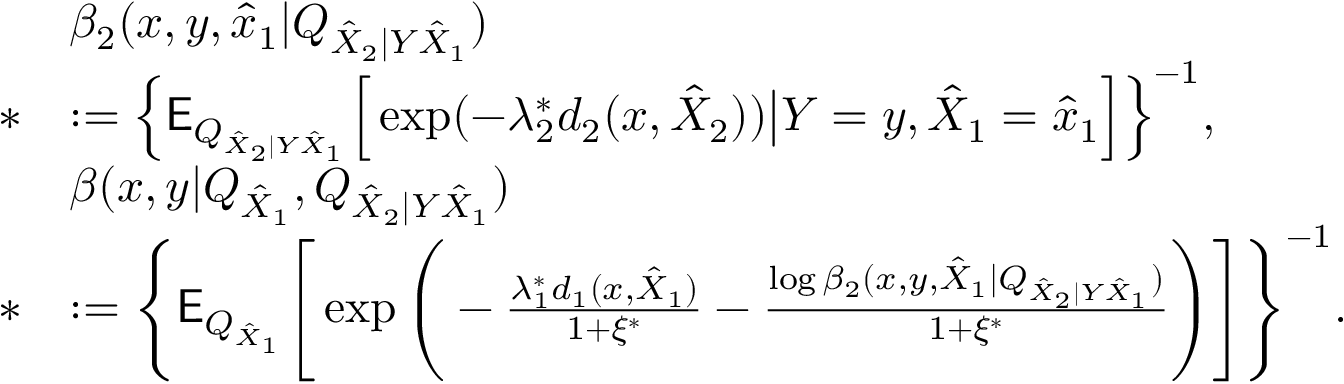Convert formula to latex. <formula><loc_0><loc_0><loc_500><loc_500>\begin{array} { r l } & { \beta _ { 2 } ( x , y , \hat { x } _ { 1 } | Q _ { \hat { X } _ { 2 } | Y \hat { X } _ { 1 } } ) } \\ { * } & { \colon = \Big \{ E _ { Q _ { \hat { X } _ { 2 } | Y \hat { X } _ { 1 } } } \Big [ \exp ( - \lambda _ { 2 } ^ { * } d _ { 2 } ( x , \hat { X } _ { 2 } ) ) \Big | Y = y , \hat { X } _ { 1 } = \hat { x } _ { 1 } \Big ] \Big \} ^ { - 1 } , } \\ & { \beta ( x , y | Q _ { \hat { X } _ { 1 } } , Q _ { \hat { X } _ { 2 } | Y \hat { X } _ { 1 } } ) } \\ { * } & { \colon = \Big \{ E _ { Q _ { \hat { X } _ { 1 } } } \Big [ \exp \Big ( - \frac { \lambda _ { 1 } ^ { * } d _ { 1 } ( x , \hat { X } _ { 1 } ) } { 1 + \xi ^ { * } } - \frac { \log \beta _ { 2 } ( x , y , \hat { X } _ { 1 } | Q _ { \hat { X } _ { 2 } | Y \hat { X } _ { 1 } } ) } { 1 + \xi ^ { * } } \Big ) \Big ] \Big \} ^ { - 1 } . } \end{array}</formula> 